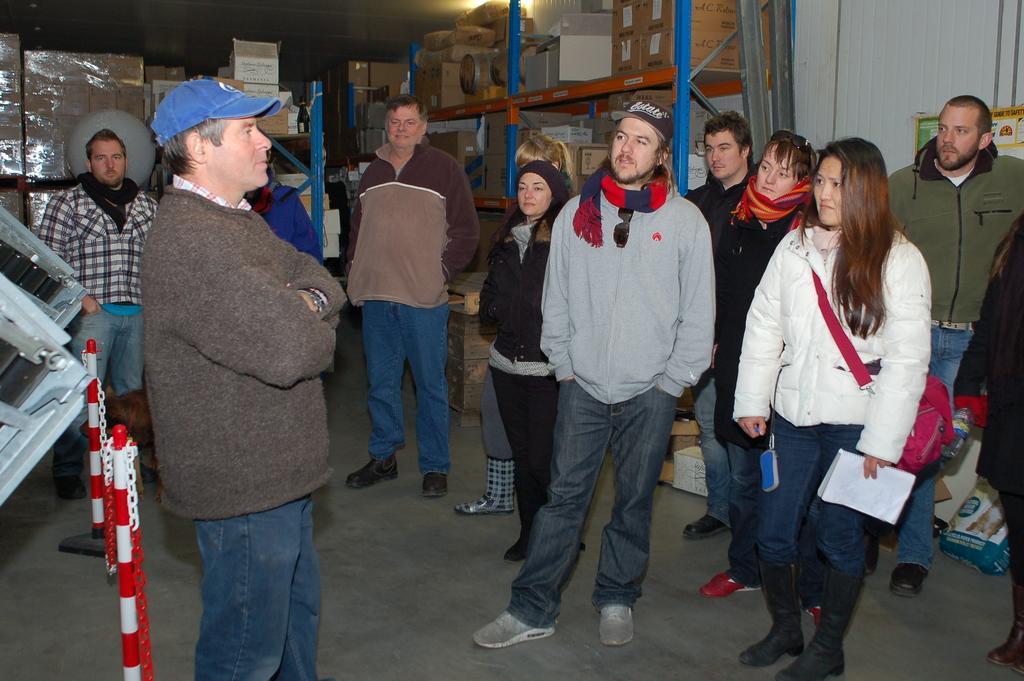How would you summarize this image in a sentence or two? In this picture we can see a group of people standing on the floor, caps, bag, book, poles, chains, boxes in racks, posters on the wall and some objects. 